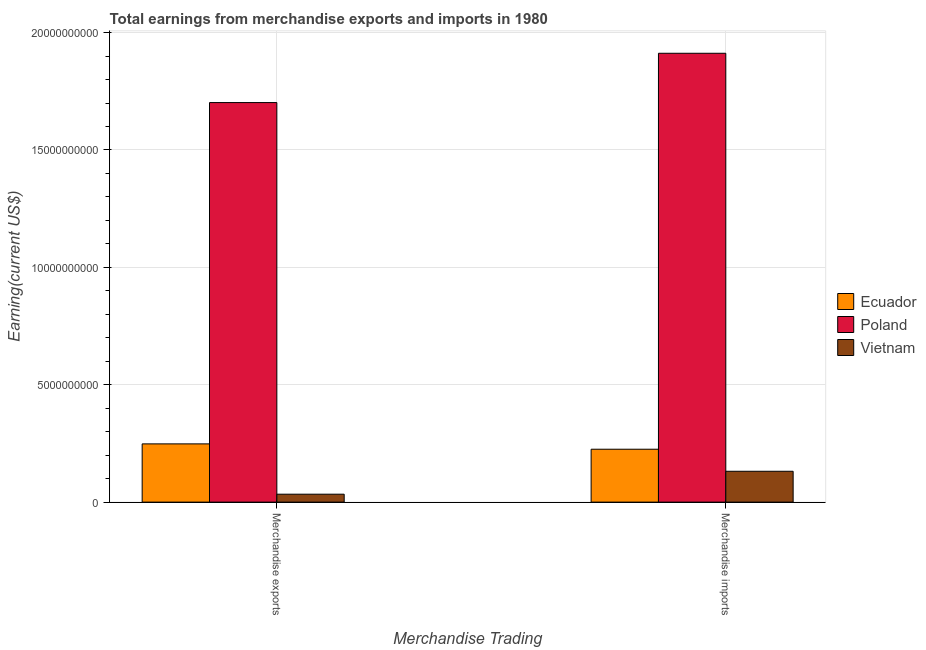How many groups of bars are there?
Offer a terse response. 2. Are the number of bars per tick equal to the number of legend labels?
Make the answer very short. Yes. What is the earnings from merchandise exports in Poland?
Provide a short and direct response. 1.70e+1. Across all countries, what is the maximum earnings from merchandise exports?
Give a very brief answer. 1.70e+1. Across all countries, what is the minimum earnings from merchandise exports?
Your answer should be compact. 3.38e+08. In which country was the earnings from merchandise exports maximum?
Offer a very short reply. Poland. In which country was the earnings from merchandise imports minimum?
Ensure brevity in your answer.  Vietnam. What is the total earnings from merchandise exports in the graph?
Your answer should be very brief. 1.98e+1. What is the difference between the earnings from merchandise imports in Vietnam and that in Ecuador?
Make the answer very short. -9.39e+08. What is the difference between the earnings from merchandise imports in Vietnam and the earnings from merchandise exports in Ecuador?
Ensure brevity in your answer.  -1.17e+09. What is the average earnings from merchandise exports per country?
Your answer should be compact. 6.61e+09. What is the difference between the earnings from merchandise exports and earnings from merchandise imports in Vietnam?
Offer a terse response. -9.76e+08. What is the ratio of the earnings from merchandise imports in Ecuador to that in Poland?
Ensure brevity in your answer.  0.12. Is the earnings from merchandise exports in Poland less than that in Ecuador?
Your response must be concise. No. In how many countries, is the earnings from merchandise exports greater than the average earnings from merchandise exports taken over all countries?
Your response must be concise. 1. What does the 3rd bar from the left in Merchandise exports represents?
Make the answer very short. Vietnam. What does the 2nd bar from the right in Merchandise exports represents?
Provide a short and direct response. Poland. How many bars are there?
Keep it short and to the point. 6. Are all the bars in the graph horizontal?
Provide a succinct answer. No. What is the difference between two consecutive major ticks on the Y-axis?
Your response must be concise. 5.00e+09. Are the values on the major ticks of Y-axis written in scientific E-notation?
Provide a short and direct response. No. Does the graph contain any zero values?
Give a very brief answer. No. Does the graph contain grids?
Your answer should be very brief. Yes. What is the title of the graph?
Your response must be concise. Total earnings from merchandise exports and imports in 1980. What is the label or title of the X-axis?
Offer a terse response. Merchandise Trading. What is the label or title of the Y-axis?
Give a very brief answer. Earning(current US$). What is the Earning(current US$) of Ecuador in Merchandise exports?
Offer a terse response. 2.48e+09. What is the Earning(current US$) in Poland in Merchandise exports?
Make the answer very short. 1.70e+1. What is the Earning(current US$) of Vietnam in Merchandise exports?
Ensure brevity in your answer.  3.38e+08. What is the Earning(current US$) of Ecuador in Merchandise imports?
Ensure brevity in your answer.  2.25e+09. What is the Earning(current US$) of Poland in Merchandise imports?
Offer a terse response. 1.91e+1. What is the Earning(current US$) of Vietnam in Merchandise imports?
Keep it short and to the point. 1.31e+09. Across all Merchandise Trading, what is the maximum Earning(current US$) in Ecuador?
Make the answer very short. 2.48e+09. Across all Merchandise Trading, what is the maximum Earning(current US$) in Poland?
Ensure brevity in your answer.  1.91e+1. Across all Merchandise Trading, what is the maximum Earning(current US$) of Vietnam?
Your answer should be very brief. 1.31e+09. Across all Merchandise Trading, what is the minimum Earning(current US$) in Ecuador?
Provide a succinct answer. 2.25e+09. Across all Merchandise Trading, what is the minimum Earning(current US$) of Poland?
Offer a very short reply. 1.70e+1. Across all Merchandise Trading, what is the minimum Earning(current US$) of Vietnam?
Offer a terse response. 3.38e+08. What is the total Earning(current US$) of Ecuador in the graph?
Your response must be concise. 4.73e+09. What is the total Earning(current US$) of Poland in the graph?
Keep it short and to the point. 3.61e+1. What is the total Earning(current US$) in Vietnam in the graph?
Provide a succinct answer. 1.65e+09. What is the difference between the Earning(current US$) of Ecuador in Merchandise exports and that in Merchandise imports?
Your response must be concise. 2.28e+08. What is the difference between the Earning(current US$) of Poland in Merchandise exports and that in Merchandise imports?
Your response must be concise. -2.10e+09. What is the difference between the Earning(current US$) of Vietnam in Merchandise exports and that in Merchandise imports?
Provide a succinct answer. -9.76e+08. What is the difference between the Earning(current US$) of Ecuador in Merchandise exports and the Earning(current US$) of Poland in Merchandise imports?
Give a very brief answer. -1.66e+1. What is the difference between the Earning(current US$) in Ecuador in Merchandise exports and the Earning(current US$) in Vietnam in Merchandise imports?
Your response must be concise. 1.17e+09. What is the difference between the Earning(current US$) in Poland in Merchandise exports and the Earning(current US$) in Vietnam in Merchandise imports?
Provide a short and direct response. 1.57e+1. What is the average Earning(current US$) in Ecuador per Merchandise Trading?
Ensure brevity in your answer.  2.37e+09. What is the average Earning(current US$) in Poland per Merchandise Trading?
Provide a succinct answer. 1.81e+1. What is the average Earning(current US$) of Vietnam per Merchandise Trading?
Ensure brevity in your answer.  8.26e+08. What is the difference between the Earning(current US$) in Ecuador and Earning(current US$) in Poland in Merchandise exports?
Provide a succinct answer. -1.45e+1. What is the difference between the Earning(current US$) of Ecuador and Earning(current US$) of Vietnam in Merchandise exports?
Make the answer very short. 2.14e+09. What is the difference between the Earning(current US$) in Poland and Earning(current US$) in Vietnam in Merchandise exports?
Ensure brevity in your answer.  1.67e+1. What is the difference between the Earning(current US$) of Ecuador and Earning(current US$) of Poland in Merchandise imports?
Your answer should be very brief. -1.69e+1. What is the difference between the Earning(current US$) of Ecuador and Earning(current US$) of Vietnam in Merchandise imports?
Provide a short and direct response. 9.39e+08. What is the difference between the Earning(current US$) of Poland and Earning(current US$) of Vietnam in Merchandise imports?
Your response must be concise. 1.78e+1. What is the ratio of the Earning(current US$) of Ecuador in Merchandise exports to that in Merchandise imports?
Keep it short and to the point. 1.1. What is the ratio of the Earning(current US$) of Poland in Merchandise exports to that in Merchandise imports?
Make the answer very short. 0.89. What is the ratio of the Earning(current US$) of Vietnam in Merchandise exports to that in Merchandise imports?
Keep it short and to the point. 0.26. What is the difference between the highest and the second highest Earning(current US$) in Ecuador?
Your response must be concise. 2.28e+08. What is the difference between the highest and the second highest Earning(current US$) of Poland?
Keep it short and to the point. 2.10e+09. What is the difference between the highest and the second highest Earning(current US$) in Vietnam?
Offer a very short reply. 9.76e+08. What is the difference between the highest and the lowest Earning(current US$) of Ecuador?
Ensure brevity in your answer.  2.28e+08. What is the difference between the highest and the lowest Earning(current US$) in Poland?
Make the answer very short. 2.10e+09. What is the difference between the highest and the lowest Earning(current US$) in Vietnam?
Make the answer very short. 9.76e+08. 